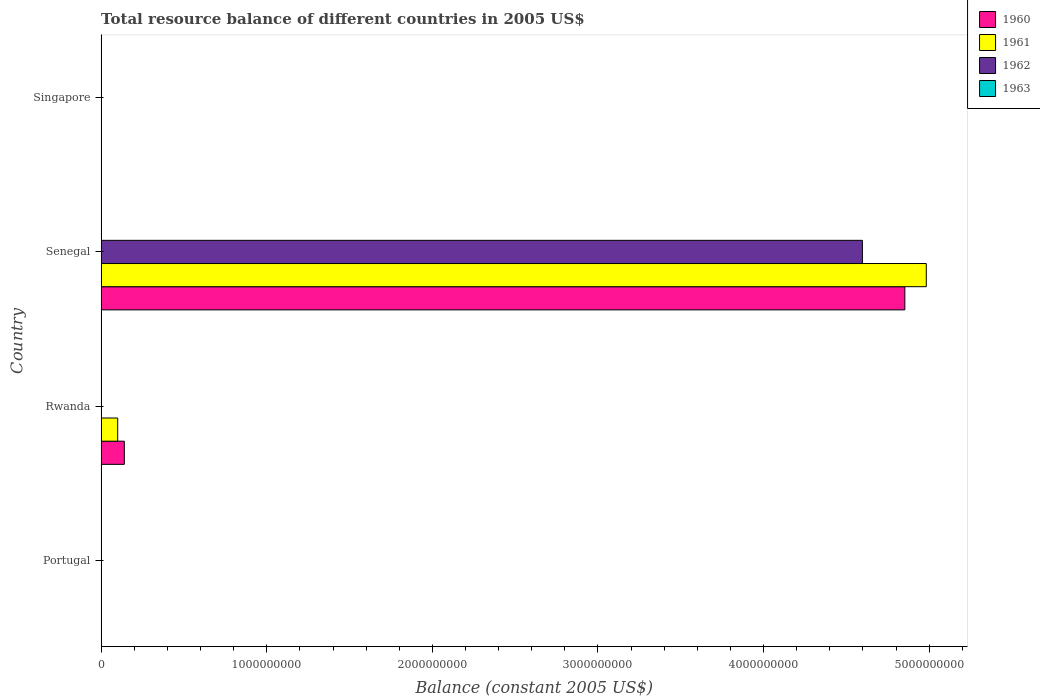Are the number of bars per tick equal to the number of legend labels?
Provide a short and direct response. No. How many bars are there on the 1st tick from the top?
Provide a short and direct response. 0. In how many cases, is the number of bars for a given country not equal to the number of legend labels?
Your response must be concise. 4. Across all countries, what is the maximum total resource balance in 1961?
Offer a very short reply. 4.98e+09. Across all countries, what is the minimum total resource balance in 1963?
Keep it short and to the point. 0. In which country was the total resource balance in 1960 maximum?
Offer a very short reply. Senegal. What is the total total resource balance in 1962 in the graph?
Offer a very short reply. 4.60e+09. What is the average total resource balance in 1960 per country?
Give a very brief answer. 1.25e+09. What is the difference between the total resource balance in 1961 and total resource balance in 1960 in Senegal?
Your answer should be compact. 1.30e+08. What is the difference between the highest and the lowest total resource balance in 1960?
Keep it short and to the point. 4.85e+09. Is the sum of the total resource balance in 1961 in Rwanda and Senegal greater than the maximum total resource balance in 1962 across all countries?
Offer a very short reply. Yes. Is it the case that in every country, the sum of the total resource balance in 1960 and total resource balance in 1962 is greater than the sum of total resource balance in 1961 and total resource balance in 1963?
Provide a succinct answer. No. Is it the case that in every country, the sum of the total resource balance in 1963 and total resource balance in 1960 is greater than the total resource balance in 1961?
Keep it short and to the point. No. Are all the bars in the graph horizontal?
Keep it short and to the point. Yes. Does the graph contain any zero values?
Ensure brevity in your answer.  Yes. Does the graph contain grids?
Provide a succinct answer. No. How are the legend labels stacked?
Your answer should be very brief. Vertical. What is the title of the graph?
Offer a terse response. Total resource balance of different countries in 2005 US$. What is the label or title of the X-axis?
Provide a short and direct response. Balance (constant 2005 US$). What is the Balance (constant 2005 US$) of 1961 in Portugal?
Your answer should be compact. 0. What is the Balance (constant 2005 US$) of 1962 in Portugal?
Provide a succinct answer. 0. What is the Balance (constant 2005 US$) in 1960 in Rwanda?
Offer a terse response. 1.40e+08. What is the Balance (constant 2005 US$) in 1961 in Rwanda?
Your response must be concise. 1.00e+08. What is the Balance (constant 2005 US$) of 1962 in Rwanda?
Your answer should be compact. 0. What is the Balance (constant 2005 US$) of 1963 in Rwanda?
Your response must be concise. 0. What is the Balance (constant 2005 US$) in 1960 in Senegal?
Your answer should be very brief. 4.85e+09. What is the Balance (constant 2005 US$) in 1961 in Senegal?
Your response must be concise. 4.98e+09. What is the Balance (constant 2005 US$) of 1962 in Senegal?
Your response must be concise. 4.60e+09. What is the Balance (constant 2005 US$) of 1960 in Singapore?
Your response must be concise. 0. What is the Balance (constant 2005 US$) of 1963 in Singapore?
Offer a very short reply. 0. Across all countries, what is the maximum Balance (constant 2005 US$) of 1960?
Your answer should be compact. 4.85e+09. Across all countries, what is the maximum Balance (constant 2005 US$) of 1961?
Give a very brief answer. 4.98e+09. Across all countries, what is the maximum Balance (constant 2005 US$) in 1962?
Offer a terse response. 4.60e+09. Across all countries, what is the minimum Balance (constant 2005 US$) in 1960?
Ensure brevity in your answer.  0. Across all countries, what is the minimum Balance (constant 2005 US$) of 1961?
Give a very brief answer. 0. Across all countries, what is the minimum Balance (constant 2005 US$) in 1962?
Give a very brief answer. 0. What is the total Balance (constant 2005 US$) in 1960 in the graph?
Offer a very short reply. 4.99e+09. What is the total Balance (constant 2005 US$) in 1961 in the graph?
Offer a very short reply. 5.08e+09. What is the total Balance (constant 2005 US$) of 1962 in the graph?
Provide a short and direct response. 4.60e+09. What is the difference between the Balance (constant 2005 US$) in 1960 in Rwanda and that in Senegal?
Keep it short and to the point. -4.71e+09. What is the difference between the Balance (constant 2005 US$) in 1961 in Rwanda and that in Senegal?
Your answer should be compact. -4.88e+09. What is the difference between the Balance (constant 2005 US$) in 1960 in Rwanda and the Balance (constant 2005 US$) in 1961 in Senegal?
Your response must be concise. -4.84e+09. What is the difference between the Balance (constant 2005 US$) in 1960 in Rwanda and the Balance (constant 2005 US$) in 1962 in Senegal?
Provide a succinct answer. -4.46e+09. What is the difference between the Balance (constant 2005 US$) of 1961 in Rwanda and the Balance (constant 2005 US$) of 1962 in Senegal?
Your answer should be compact. -4.50e+09. What is the average Balance (constant 2005 US$) in 1960 per country?
Your answer should be very brief. 1.25e+09. What is the average Balance (constant 2005 US$) of 1961 per country?
Ensure brevity in your answer.  1.27e+09. What is the average Balance (constant 2005 US$) in 1962 per country?
Provide a short and direct response. 1.15e+09. What is the difference between the Balance (constant 2005 US$) of 1960 and Balance (constant 2005 US$) of 1961 in Rwanda?
Your answer should be compact. 4.00e+07. What is the difference between the Balance (constant 2005 US$) of 1960 and Balance (constant 2005 US$) of 1961 in Senegal?
Your answer should be compact. -1.30e+08. What is the difference between the Balance (constant 2005 US$) of 1960 and Balance (constant 2005 US$) of 1962 in Senegal?
Your response must be concise. 2.56e+08. What is the difference between the Balance (constant 2005 US$) of 1961 and Balance (constant 2005 US$) of 1962 in Senegal?
Provide a succinct answer. 3.86e+08. What is the ratio of the Balance (constant 2005 US$) of 1960 in Rwanda to that in Senegal?
Your answer should be very brief. 0.03. What is the ratio of the Balance (constant 2005 US$) in 1961 in Rwanda to that in Senegal?
Your response must be concise. 0.02. What is the difference between the highest and the lowest Balance (constant 2005 US$) of 1960?
Offer a terse response. 4.85e+09. What is the difference between the highest and the lowest Balance (constant 2005 US$) in 1961?
Offer a very short reply. 4.98e+09. What is the difference between the highest and the lowest Balance (constant 2005 US$) in 1962?
Keep it short and to the point. 4.60e+09. 